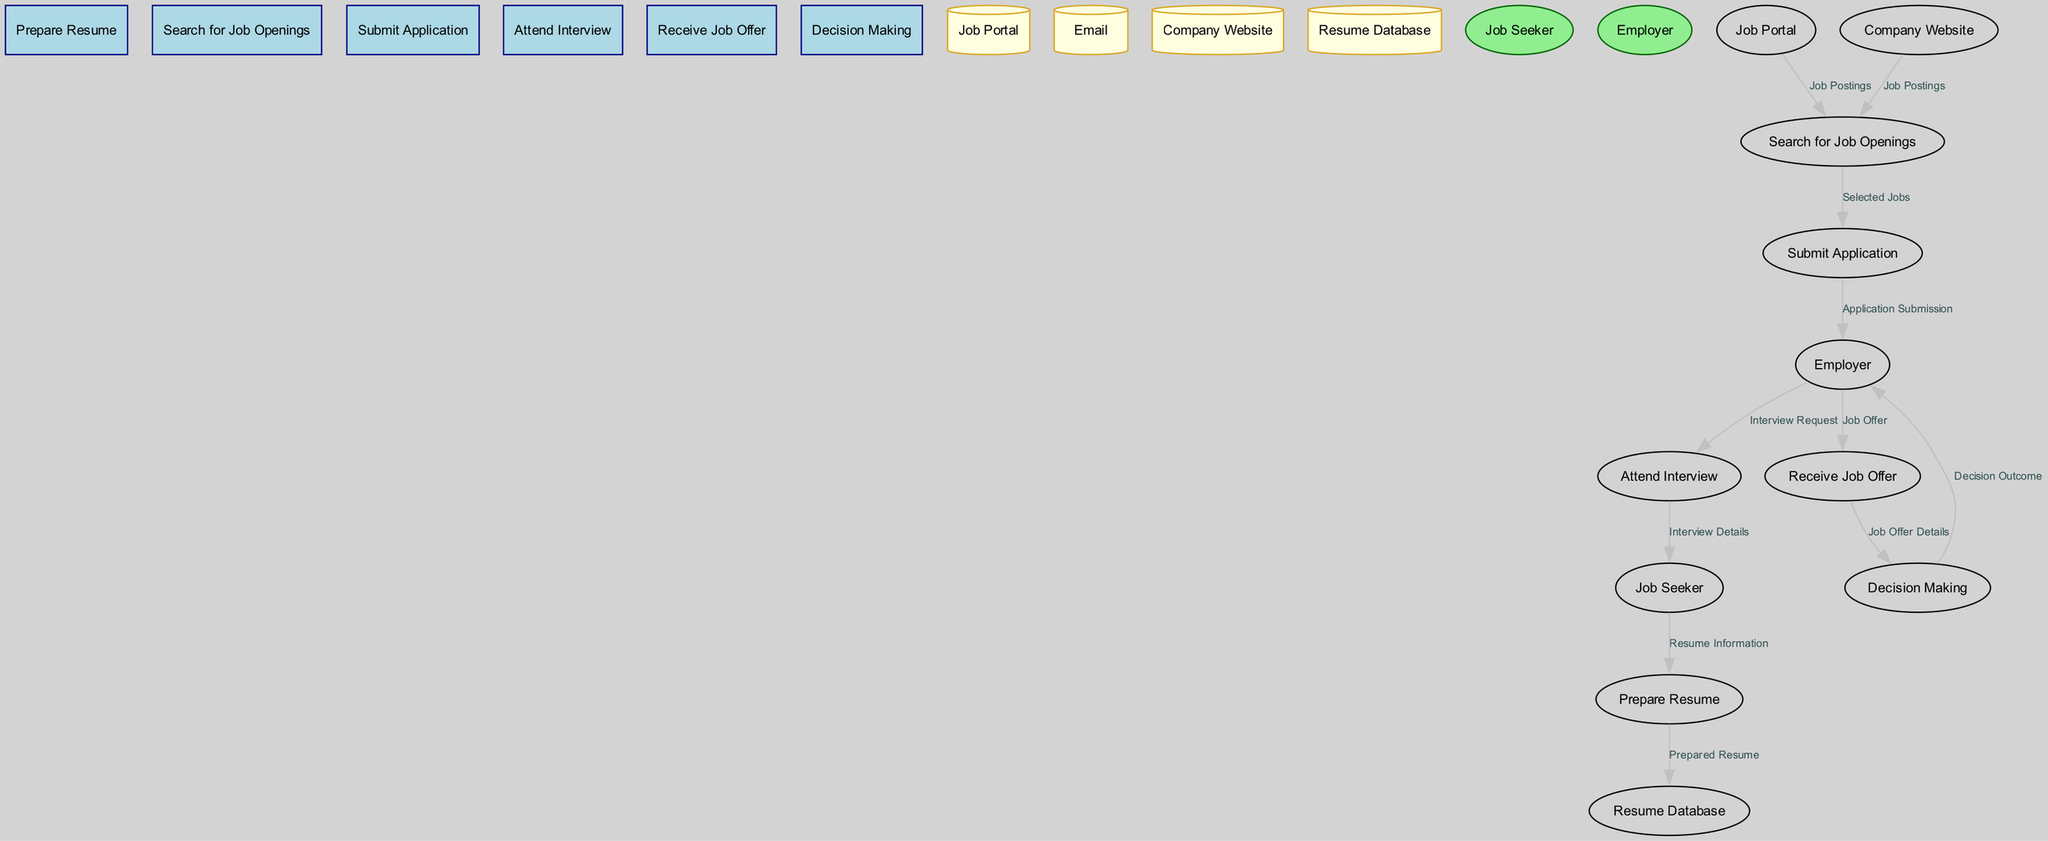What is the first process in the job application flow? The diagram lists "Prepare Resume" as the first process, as it is shown at the top of the flow.
Answer: Prepare Resume How many data stores are present in the diagram? By counting the labeled nodes that represent data stores, we find four: Job Portal, Email, Company Website, and Resume Database.
Answer: 4 What is the source of the flow labeled 'Application Submission'? The diagram indicates that the 'Application Submission' flow originates from the 'Submit Application' process, which is shown as leading to the Employer.
Answer: Submit Application Which entity is responsible for providing 'Job Offer' information? The 'Job Offer' flow comes from the Employer, indicating that the employer is the source of this information in the diagram.
Answer: Employer What flow connects 'Receive Job Offer' to 'Decision Making'? The flow from 'Receive Job Offer' to 'Decision Making' is labeled 'Job Offer Details', indicating the specific information that leads to the decision-making step.
Answer: Job Offer Details What is the last process in the job application flow? The last process in the flow is 'Decision Making', which appears at the bottom of the diagram, indicating it is the final step before concluding the job application process.
Answer: Decision Making How many total processes are depicted in the diagram? Counting the labeled processes, there are six in total: Prepare Resume, Search for Job Openings, Submit Application, Attend Interview, Receive Job Offer, and Decision Making.
Answer: 6 Which data store is used to find job postings? The 'Job Portal' and 'Company Website' data stores are used to retrieve job postings, as indicated by the flows directed towards the 'Search for Job Openings' process.
Answer: Job Portal, Company Website What flow is sent from the Job Seeker to 'Prepare Resume'? The flow is labeled 'Resume Information', indicating the job seeker is providing information needed to prepare their resume.
Answer: Resume Information 